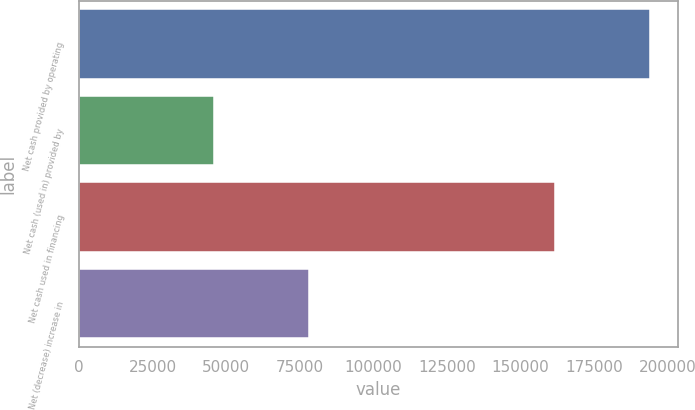Convert chart. <chart><loc_0><loc_0><loc_500><loc_500><bar_chart><fcel>Net cash provided by operating<fcel>Net cash (used in) provided by<fcel>Net cash used in financing<fcel>Net (decrease) increase in<nl><fcel>193862<fcel>45729<fcel>161647<fcel>77944<nl></chart> 